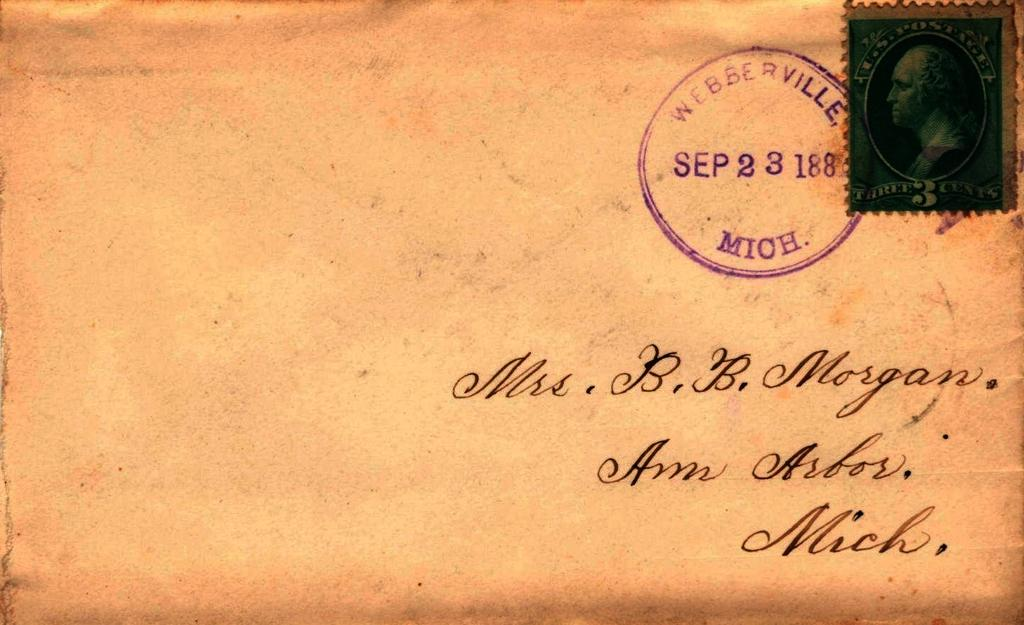<image>
Render a clear and concise summary of the photo. An envelope is addressed to Mrs. B.B. Morgan. 